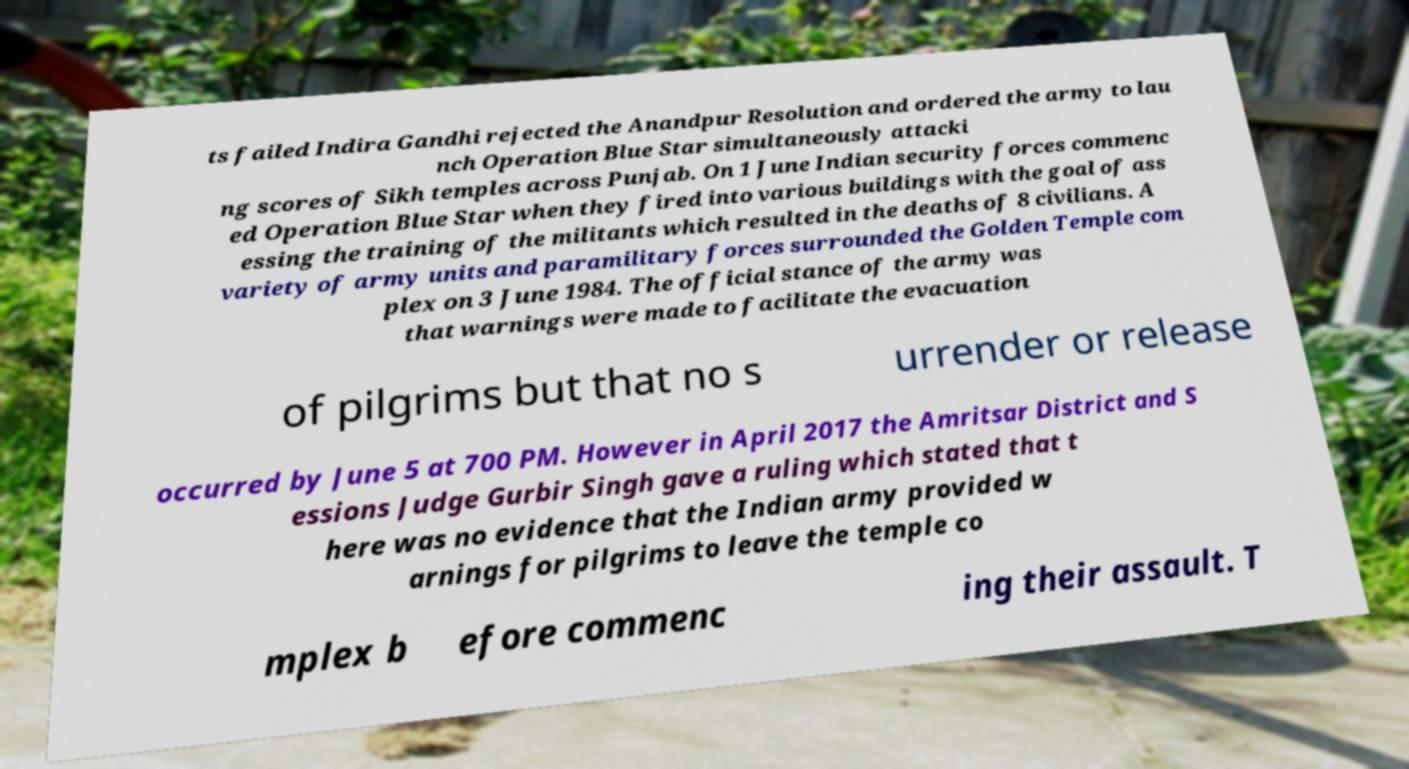There's text embedded in this image that I need extracted. Can you transcribe it verbatim? ts failed Indira Gandhi rejected the Anandpur Resolution and ordered the army to lau nch Operation Blue Star simultaneously attacki ng scores of Sikh temples across Punjab. On 1 June Indian security forces commenc ed Operation Blue Star when they fired into various buildings with the goal of ass essing the training of the militants which resulted in the deaths of 8 civilians. A variety of army units and paramilitary forces surrounded the Golden Temple com plex on 3 June 1984. The official stance of the army was that warnings were made to facilitate the evacuation of pilgrims but that no s urrender or release occurred by June 5 at 700 PM. However in April 2017 the Amritsar District and S essions Judge Gurbir Singh gave a ruling which stated that t here was no evidence that the Indian army provided w arnings for pilgrims to leave the temple co mplex b efore commenc ing their assault. T 